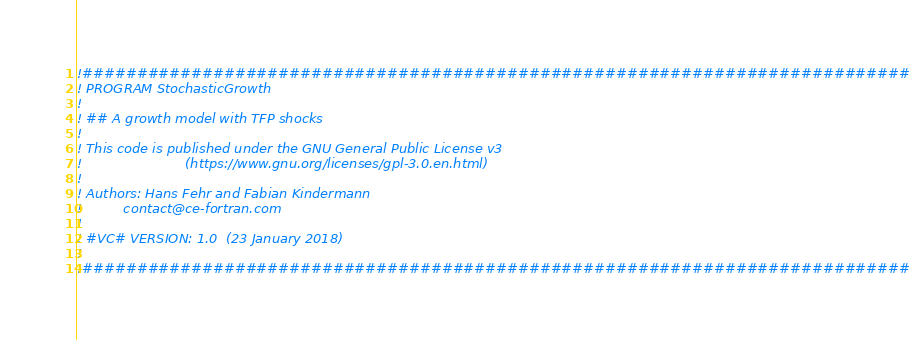Convert code to text. <code><loc_0><loc_0><loc_500><loc_500><_FORTRAN_>!##############################################################################
! PROGRAM StochasticGrowth
!
! ## A growth model with TFP shocks
!
! This code is published under the GNU General Public License v3
!                         (https://www.gnu.org/licenses/gpl-3.0.en.html)
!
! Authors: Hans Fehr and Fabian Kindermann
!          contact@ce-fortran.com
!
! #VC# VERSION: 1.0  (23 January 2018)
!
!##############################################################################</code> 